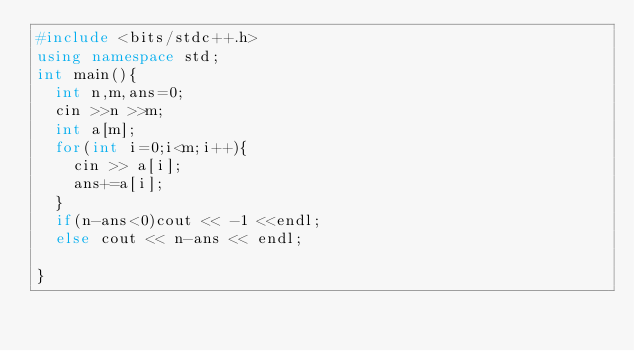Convert code to text. <code><loc_0><loc_0><loc_500><loc_500><_C++_>#include <bits/stdc++.h>
using namespace std;
int main(){
  int n,m,ans=0;
  cin >>n >>m;
  int a[m];
  for(int i=0;i<m;i++){
    cin >> a[i];
    ans+=a[i];
  }
  if(n-ans<0)cout << -1 <<endl;
  else cout << n-ans << endl;
  
}</code> 